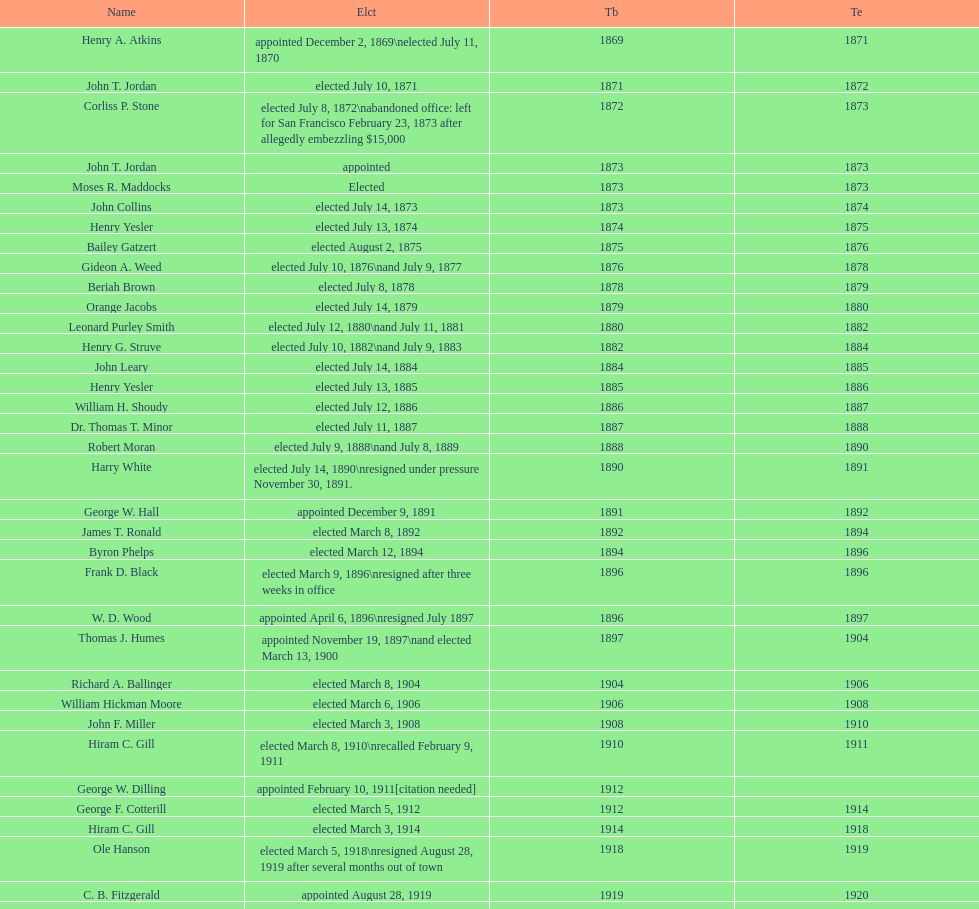Who was the only person elected in 1871? John T. Jordan. 